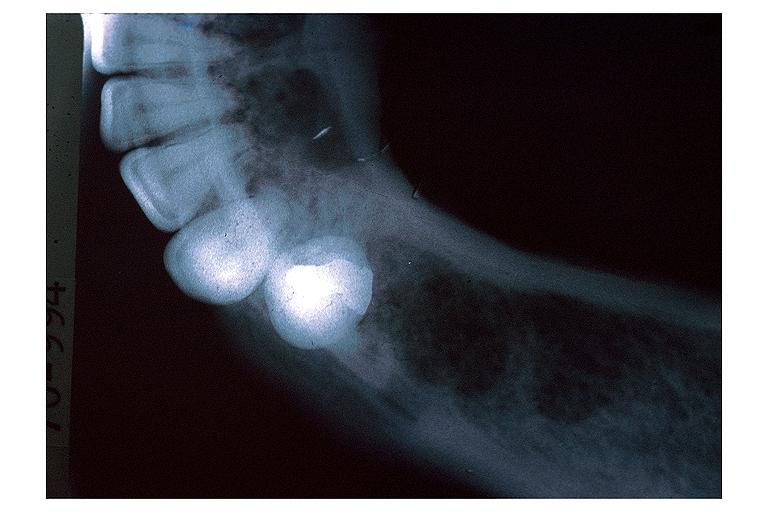s oral present?
Answer the question using a single word or phrase. Yes 